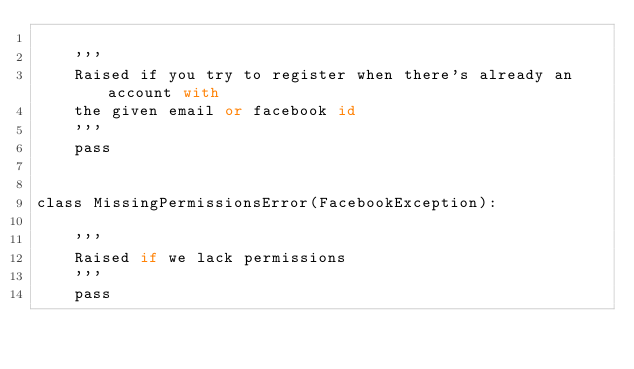<code> <loc_0><loc_0><loc_500><loc_500><_Python_>
    '''
    Raised if you try to register when there's already an account with
    the given email or facebook id
    '''
    pass


class MissingPermissionsError(FacebookException):

    '''
    Raised if we lack permissions
    '''
    pass
</code> 